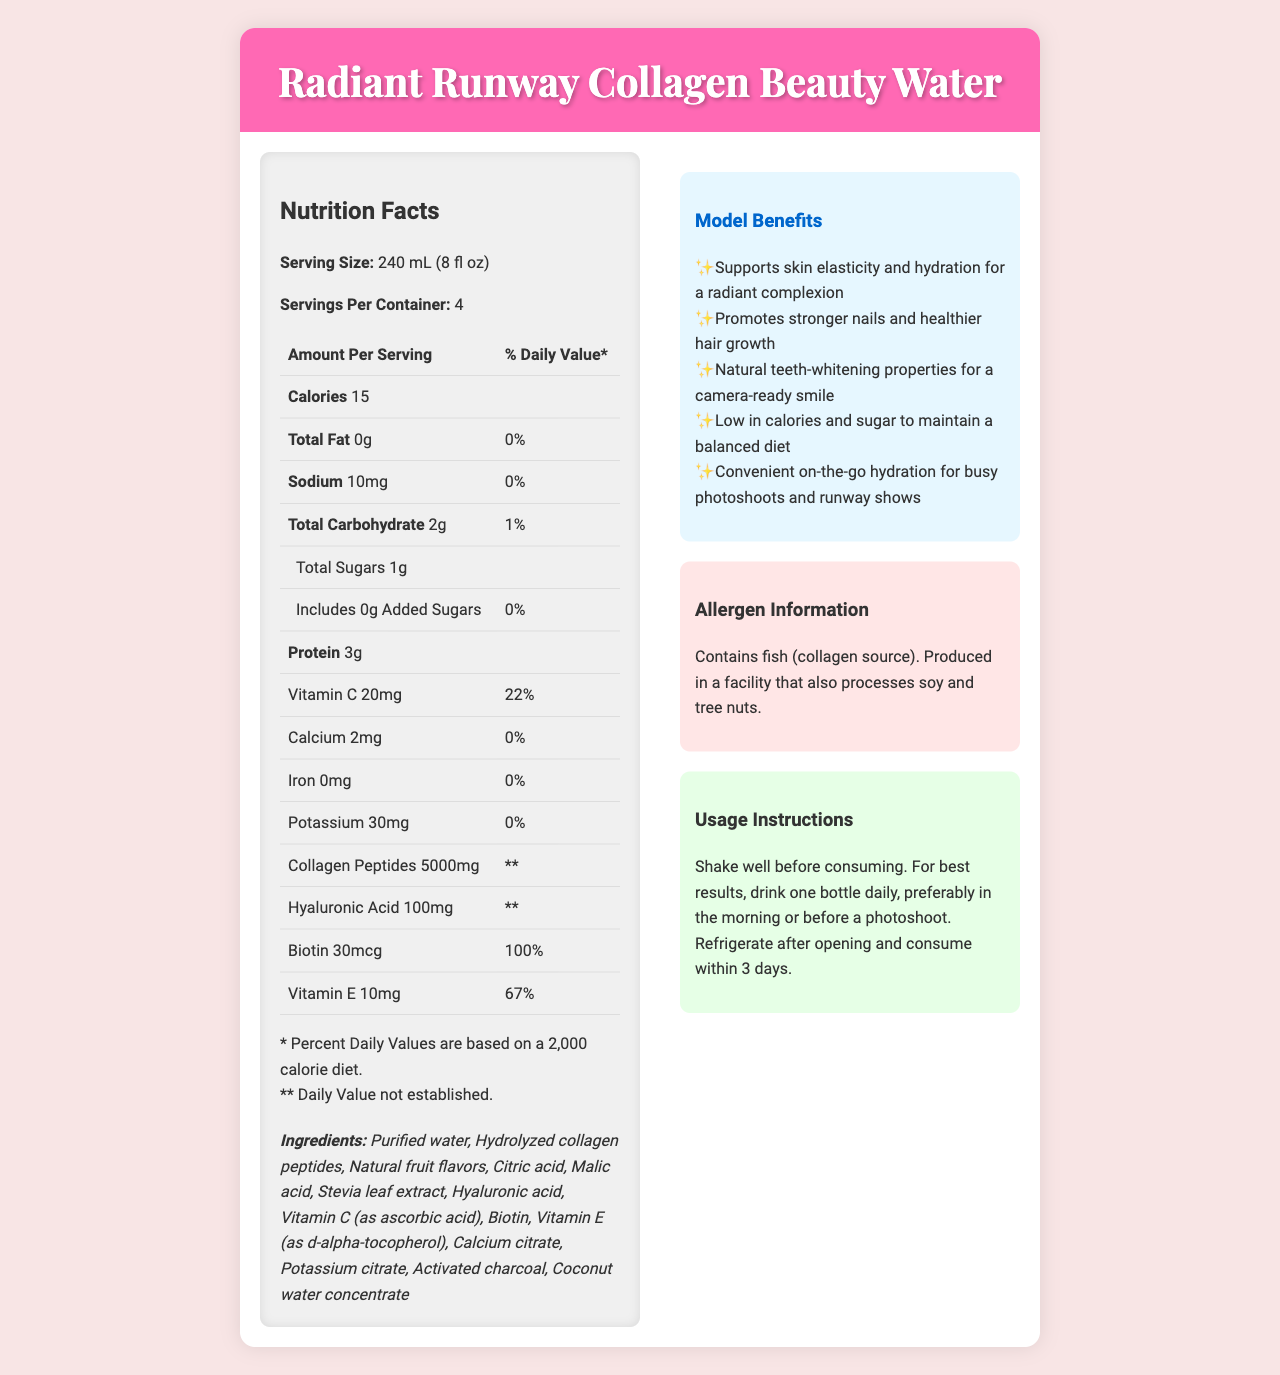What is the serving size of Radiant Runway Collagen Beauty Water? The document specifies the serving size as "240 mL (8 fl oz)".
Answer: 240 mL (8 fl oz) How many calories are in a single serving? The document lists the calorie content per serving under Nutrition Facts.
Answer: 15 calories List the key ingredients that contribute to the teeth-whitening properties. These ingredients are specified under the "teeth_whitening_blend" section of the document.
Answer: Activated charcoal, Coconut water concentrate, Malic acid What is the main source of protein in this beauty water? The primary ingredient providing protein is "Hydrolyzed collagen peptides" as listed in the ingredients.
Answer: Hydrolyzed collagen peptides What is the percentage daily value of Biotin per serving? According to the nutrition table, Biotin provides 100% of the daily value per serving.
Answer: 100% Which component supports skin elasticity and hydration? A. Activated Charcoal B. Biotin C. Hyaluronic Acid D. Stevia Leaf Extract The benefits section states that the product supports skin elasticity and hydration, and Hyaluronic Acid is known for these properties.
Answer: C. Hyaluronic Acid What essential vitamin is present in the amount of 10 mg per serving? A. Vitamin A B. Vitamin B12 C. Vitamin E D. Vitamin D The nutrient table in the document lists 10 mg of Vitamin E per serving.
Answer: C. Vitamin E Does the product contain any sugars other than added sugars? The document mentions that there is 1 gram of total sugars and 0 grams of added sugars, indicating the presence of natural sugars.
Answer: Yes Does the product contain any common allergens? The allergen information states that the product contains fish (collagen source) and is made in a facility that also processes soy and tree nuts.
Answer: Yes Summarize the main features and benefits of Radiant Runway Collagen Beauty Water. This summary captures the primary attributes, benefits, and allergen information presented in the document.
Answer: Radiant Runway Collagen Beauty Water is a low-calorie beauty drink with key ingredients like collagen peptides, hyaluronic acid, and biotin. It supports skin elasticity, hydration, stronger nails, and healthier hair growth. The product also has natural teeth-whitening properties and provides convenient on-the-go hydration. It contains fish-derived collagen and could have traces of soy and tree nuts. What is the natural sweetener used in the Radiant Runway Collagen Beauty Water? Stevia leaf extract is listed as one of the ingredients and is a natural sweetener.
Answer: Stevia leaf extract How many grams of protein does one serving contain? The document's nutrition facts indicate that each serving contains 3 grams of protein.
Answer: 3 grams Does the Radiant Runway Collagen Beauty Water contain any iron? The nutrient table shows 0 mg of iron per serving.
Answer: No What should you do after opening a bottle of Radiant Runway Collagen Beauty Water? A. Store it at room temperature B. Refrigerate it C. Freeze it D. Keep it in a cool, dark place The usage instructions advise refrigerating the product after opening.
Answer: B. Refrigerate it How long can the product be consumed after opening? The usage instructions specify that the product should be consumed within 3 days after opening.
Answer: Within 3 days What will be your unique selling points on the runway after incorporating this beauty water into your routine? The benefits section highlights that the product supports a radiant complexion and provides natural teeth-whitening properties, which are great selling points.
Answer: Radiant complexion and a camera-ready smile What is the collagen source in this beauty water? The allergen information clearly states that the collagen source is fish.
Answer: Fish Is the exact amount of the teeth-whitening blend provided in the document? The document lists the components of the teeth-whitening blend but does not specify the exact amounts of each component.
Answer: No 